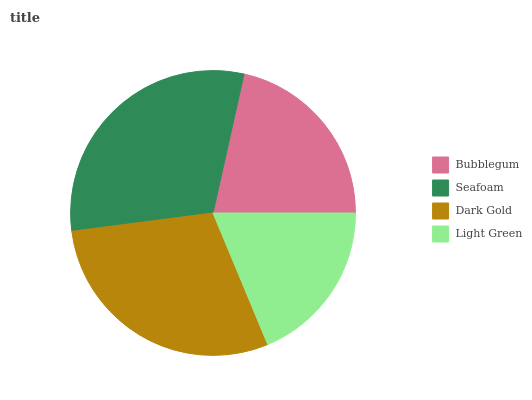Is Light Green the minimum?
Answer yes or no. Yes. Is Seafoam the maximum?
Answer yes or no. Yes. Is Dark Gold the minimum?
Answer yes or no. No. Is Dark Gold the maximum?
Answer yes or no. No. Is Seafoam greater than Dark Gold?
Answer yes or no. Yes. Is Dark Gold less than Seafoam?
Answer yes or no. Yes. Is Dark Gold greater than Seafoam?
Answer yes or no. No. Is Seafoam less than Dark Gold?
Answer yes or no. No. Is Dark Gold the high median?
Answer yes or no. Yes. Is Bubblegum the low median?
Answer yes or no. Yes. Is Seafoam the high median?
Answer yes or no. No. Is Dark Gold the low median?
Answer yes or no. No. 